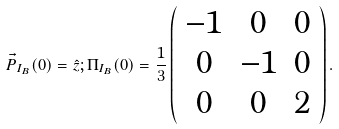<formula> <loc_0><loc_0><loc_500><loc_500>\vec { P } _ { I _ { B } } ( 0 ) = \hat { z } ; { \Pi } _ { I _ { B } } ( 0 ) = \frac { 1 } { 3 } \left ( \begin{array} { c c c } - 1 & 0 & 0 \\ 0 & - 1 & 0 \\ 0 & 0 & 2 \end{array} \right ) .</formula> 